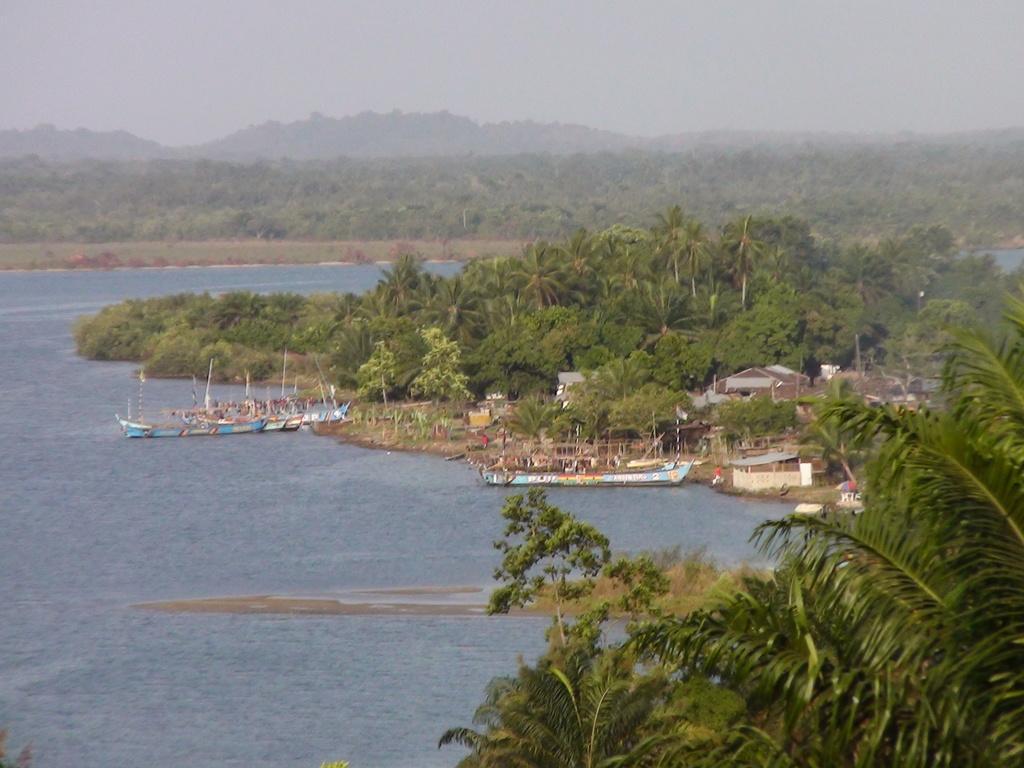Could you give a brief overview of what you see in this image? This image is taken outdoors. At the top of the image there is the sky. In the background there are a few hills and there are many trees and plants on the ground. On the left side of the image there is a pond with water. There are two boats on the pond and there are a few people in the boats. On the right side of the image there are many trees and plants with leaves, stems and branches. There are a few houses. 